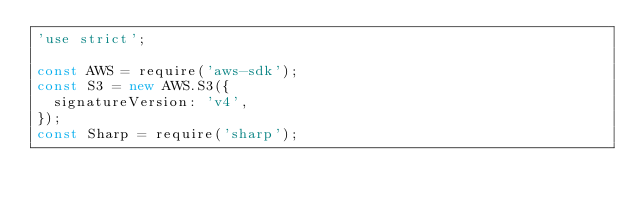Convert code to text. <code><loc_0><loc_0><loc_500><loc_500><_JavaScript_>'use strict';

const AWS = require('aws-sdk');
const S3 = new AWS.S3({
  signatureVersion: 'v4',
});
const Sharp = require('sharp');</code> 